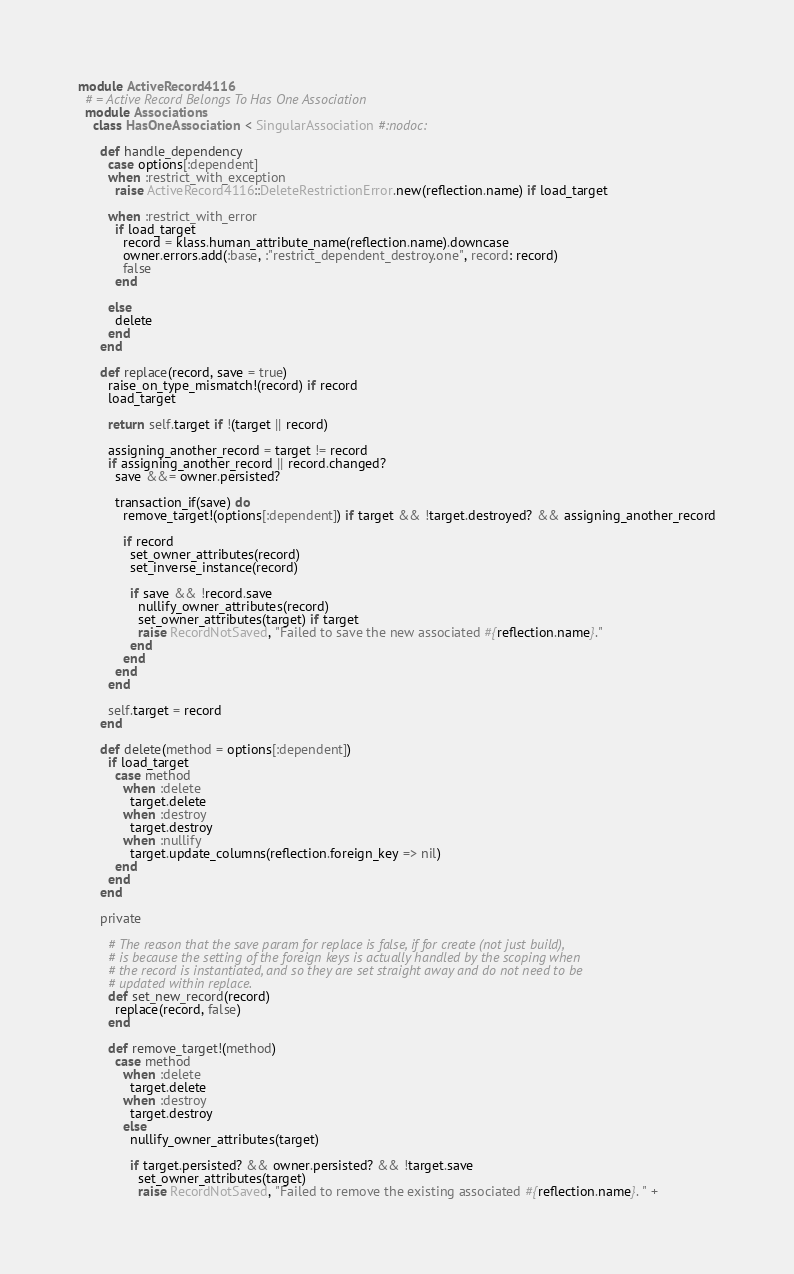Convert code to text. <code><loc_0><loc_0><loc_500><loc_500><_Ruby_>
module ActiveRecord4116
  # = Active Record Belongs To Has One Association
  module Associations
    class HasOneAssociation < SingularAssociation #:nodoc:

      def handle_dependency
        case options[:dependent]
        when :restrict_with_exception
          raise ActiveRecord4116::DeleteRestrictionError.new(reflection.name) if load_target

        when :restrict_with_error
          if load_target
            record = klass.human_attribute_name(reflection.name).downcase
            owner.errors.add(:base, :"restrict_dependent_destroy.one", record: record)
            false
          end

        else
          delete
        end
      end

      def replace(record, save = true)
        raise_on_type_mismatch!(record) if record
        load_target

        return self.target if !(target || record)

        assigning_another_record = target != record
        if assigning_another_record || record.changed?
          save &&= owner.persisted?

          transaction_if(save) do
            remove_target!(options[:dependent]) if target && !target.destroyed? && assigning_another_record

            if record
              set_owner_attributes(record)
              set_inverse_instance(record)

              if save && !record.save
                nullify_owner_attributes(record)
                set_owner_attributes(target) if target
                raise RecordNotSaved, "Failed to save the new associated #{reflection.name}."
              end
            end
          end
        end

        self.target = record
      end

      def delete(method = options[:dependent])
        if load_target
          case method
            when :delete
              target.delete
            when :destroy
              target.destroy
            when :nullify
              target.update_columns(reflection.foreign_key => nil)
          end
        end
      end

      private

        # The reason that the save param for replace is false, if for create (not just build),
        # is because the setting of the foreign keys is actually handled by the scoping when
        # the record is instantiated, and so they are set straight away and do not need to be
        # updated within replace.
        def set_new_record(record)
          replace(record, false)
        end

        def remove_target!(method)
          case method
            when :delete
              target.delete
            when :destroy
              target.destroy
            else
              nullify_owner_attributes(target)

              if target.persisted? && owner.persisted? && !target.save
                set_owner_attributes(target)
                raise RecordNotSaved, "Failed to remove the existing associated #{reflection.name}. " +</code> 